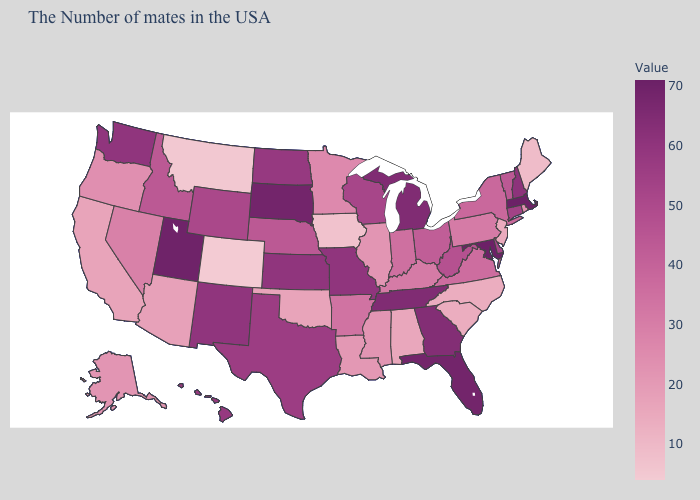Does Colorado have the lowest value in the USA?
Write a very short answer. Yes. Does the map have missing data?
Keep it brief. No. Which states have the lowest value in the USA?
Keep it brief. Colorado. 